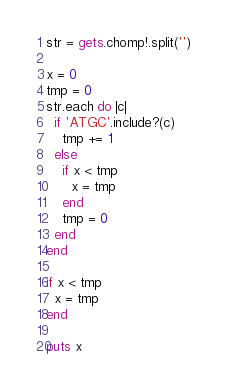Convert code to text. <code><loc_0><loc_0><loc_500><loc_500><_Ruby_>str = gets.chomp!.split('')

x = 0
tmp = 0
str.each do |c|
  if 'ATGC'.include?(c)
    tmp += 1
  else
    if x < tmp
      x = tmp
    end
    tmp = 0
  end
end

if x < tmp
  x = tmp
end

puts x
</code> 